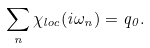Convert formula to latex. <formula><loc_0><loc_0><loc_500><loc_500>\sum _ { n } \chi _ { l o c } ( i \omega _ { n } ) = q _ { 0 } .</formula> 